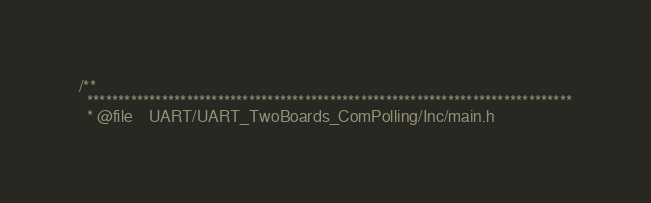Convert code to text. <code><loc_0><loc_0><loc_500><loc_500><_C_>/**
  ******************************************************************************
  * @file    UART/UART_TwoBoards_ComPolling/Inc/main.h </code> 